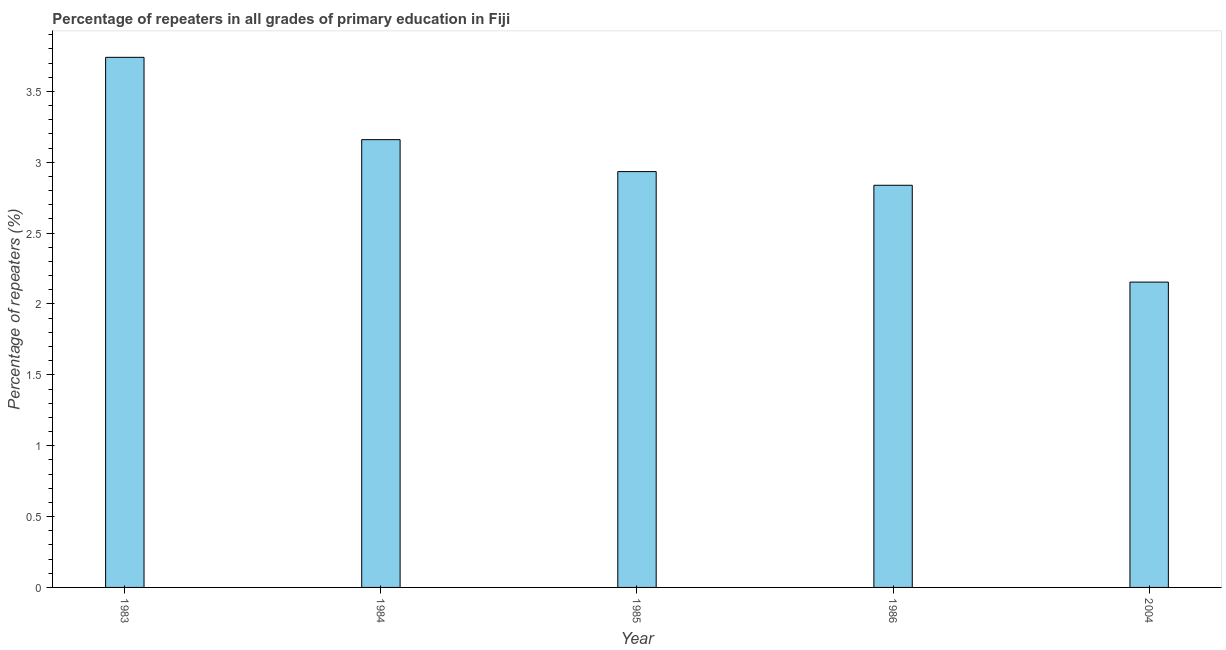Does the graph contain grids?
Keep it short and to the point. No. What is the title of the graph?
Your answer should be very brief. Percentage of repeaters in all grades of primary education in Fiji. What is the label or title of the Y-axis?
Offer a very short reply. Percentage of repeaters (%). What is the percentage of repeaters in primary education in 1983?
Keep it short and to the point. 3.74. Across all years, what is the maximum percentage of repeaters in primary education?
Your response must be concise. 3.74. Across all years, what is the minimum percentage of repeaters in primary education?
Offer a terse response. 2.15. In which year was the percentage of repeaters in primary education maximum?
Ensure brevity in your answer.  1983. In which year was the percentage of repeaters in primary education minimum?
Provide a short and direct response. 2004. What is the sum of the percentage of repeaters in primary education?
Your answer should be very brief. 14.83. What is the difference between the percentage of repeaters in primary education in 1984 and 1986?
Your answer should be very brief. 0.32. What is the average percentage of repeaters in primary education per year?
Offer a terse response. 2.96. What is the median percentage of repeaters in primary education?
Make the answer very short. 2.93. In how many years, is the percentage of repeaters in primary education greater than 2.7 %?
Your answer should be very brief. 4. Do a majority of the years between 1986 and 1985 (inclusive) have percentage of repeaters in primary education greater than 2.2 %?
Provide a succinct answer. No. What is the ratio of the percentage of repeaters in primary education in 1986 to that in 2004?
Your answer should be compact. 1.32. Is the difference between the percentage of repeaters in primary education in 1985 and 1986 greater than the difference between any two years?
Your answer should be very brief. No. What is the difference between the highest and the second highest percentage of repeaters in primary education?
Ensure brevity in your answer.  0.58. What is the difference between the highest and the lowest percentage of repeaters in primary education?
Offer a terse response. 1.59. In how many years, is the percentage of repeaters in primary education greater than the average percentage of repeaters in primary education taken over all years?
Make the answer very short. 2. How many bars are there?
Make the answer very short. 5. What is the Percentage of repeaters (%) of 1983?
Provide a short and direct response. 3.74. What is the Percentage of repeaters (%) of 1984?
Keep it short and to the point. 3.16. What is the Percentage of repeaters (%) in 1985?
Provide a succinct answer. 2.93. What is the Percentage of repeaters (%) in 1986?
Give a very brief answer. 2.84. What is the Percentage of repeaters (%) in 2004?
Your response must be concise. 2.15. What is the difference between the Percentage of repeaters (%) in 1983 and 1984?
Your answer should be very brief. 0.58. What is the difference between the Percentage of repeaters (%) in 1983 and 1985?
Ensure brevity in your answer.  0.81. What is the difference between the Percentage of repeaters (%) in 1983 and 1986?
Offer a terse response. 0.9. What is the difference between the Percentage of repeaters (%) in 1983 and 2004?
Ensure brevity in your answer.  1.59. What is the difference between the Percentage of repeaters (%) in 1984 and 1985?
Ensure brevity in your answer.  0.23. What is the difference between the Percentage of repeaters (%) in 1984 and 1986?
Offer a terse response. 0.32. What is the difference between the Percentage of repeaters (%) in 1984 and 2004?
Offer a very short reply. 1.01. What is the difference between the Percentage of repeaters (%) in 1985 and 1986?
Keep it short and to the point. 0.1. What is the difference between the Percentage of repeaters (%) in 1985 and 2004?
Offer a very short reply. 0.78. What is the difference between the Percentage of repeaters (%) in 1986 and 2004?
Your answer should be compact. 0.68. What is the ratio of the Percentage of repeaters (%) in 1983 to that in 1984?
Give a very brief answer. 1.18. What is the ratio of the Percentage of repeaters (%) in 1983 to that in 1985?
Offer a very short reply. 1.27. What is the ratio of the Percentage of repeaters (%) in 1983 to that in 1986?
Your answer should be very brief. 1.32. What is the ratio of the Percentage of repeaters (%) in 1983 to that in 2004?
Offer a terse response. 1.74. What is the ratio of the Percentage of repeaters (%) in 1984 to that in 1985?
Your answer should be compact. 1.08. What is the ratio of the Percentage of repeaters (%) in 1984 to that in 1986?
Offer a terse response. 1.11. What is the ratio of the Percentage of repeaters (%) in 1984 to that in 2004?
Your answer should be very brief. 1.47. What is the ratio of the Percentage of repeaters (%) in 1985 to that in 1986?
Your answer should be very brief. 1.03. What is the ratio of the Percentage of repeaters (%) in 1985 to that in 2004?
Ensure brevity in your answer.  1.36. What is the ratio of the Percentage of repeaters (%) in 1986 to that in 2004?
Provide a succinct answer. 1.32. 